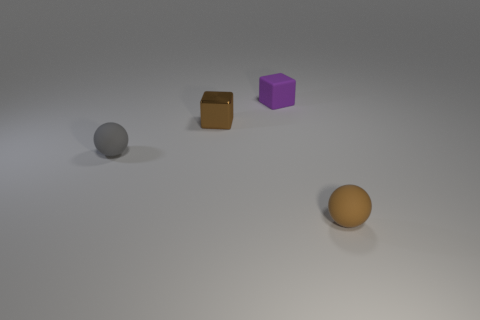Add 3 big red shiny balls. How many objects exist? 7 Add 2 brown spheres. How many brown spheres exist? 3 Subtract 0 green blocks. How many objects are left? 4 Subtract all small brown balls. Subtract all green metal objects. How many objects are left? 3 Add 3 small metal blocks. How many small metal blocks are left? 4 